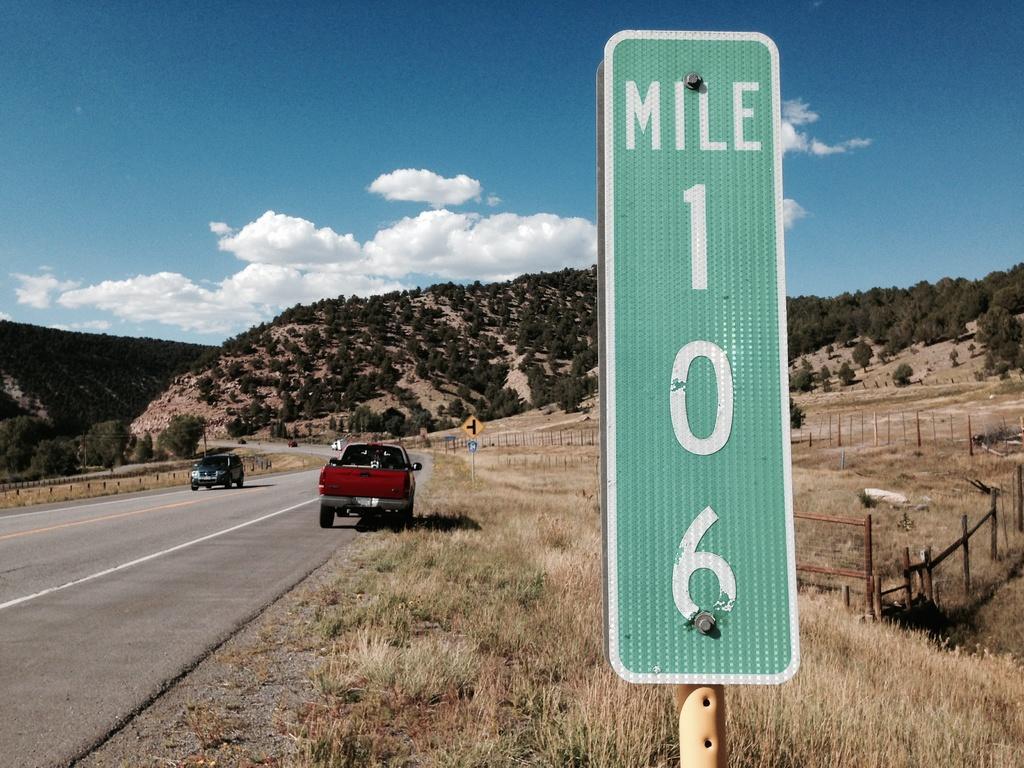In one or two sentences, can you explain what this image depicts? In this image I can see in the middle there is a board in green color. On the left side few cars are moving on the road, at the back side there are trees. At the top it is the sky, on the right side there is an iron fence. 